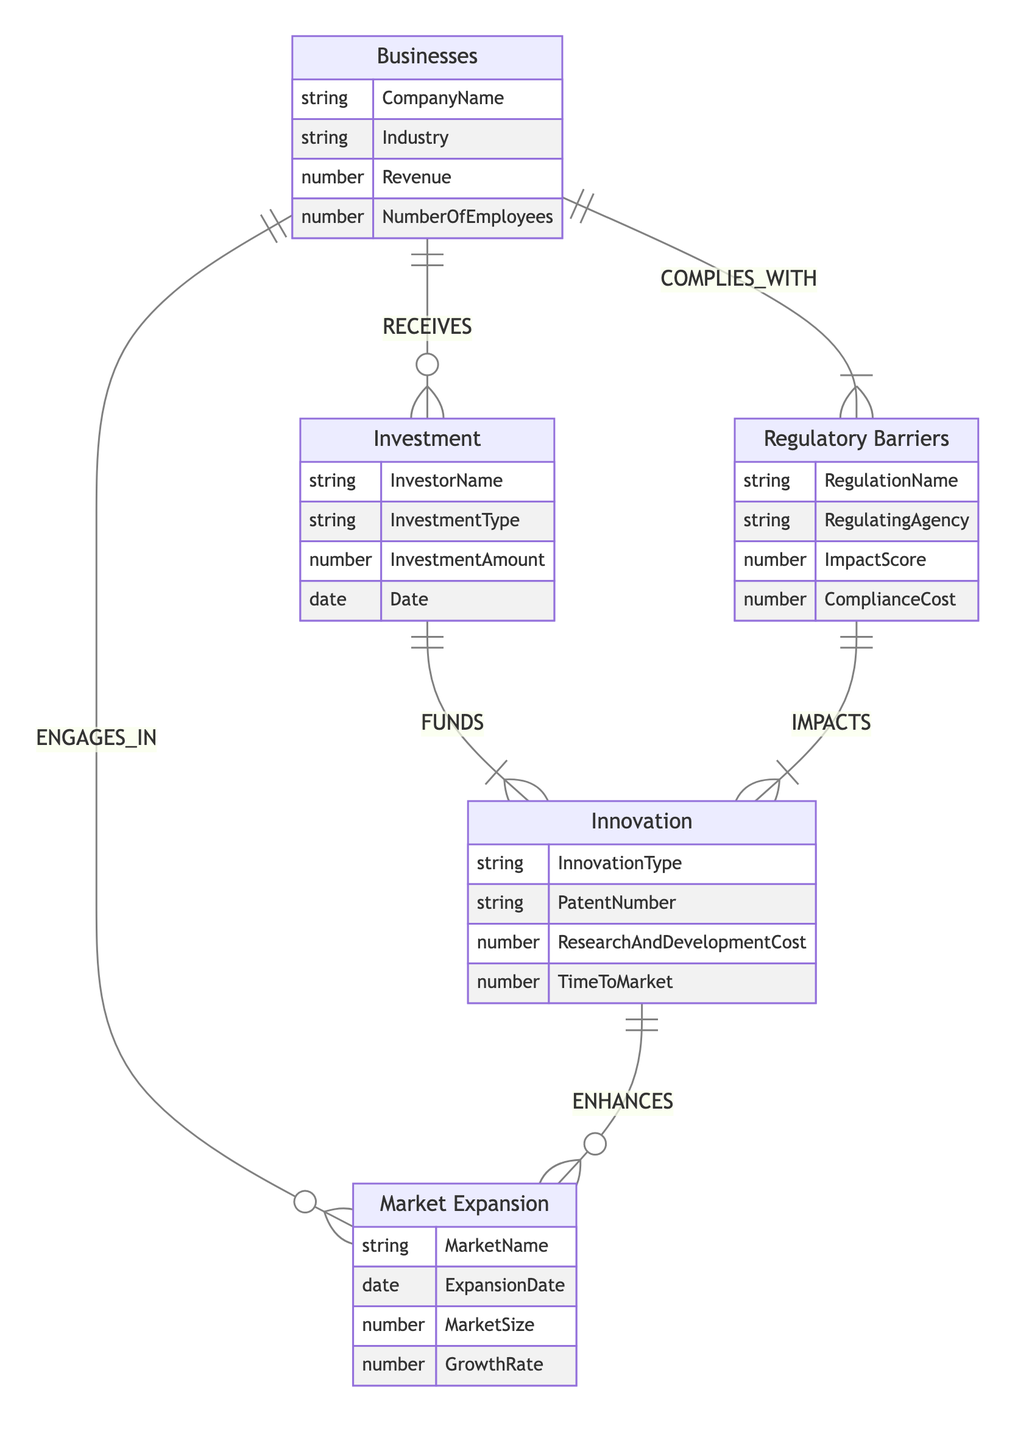What's the relationship type between Businesses and Investment? The diagram indicates that Businesses "RECEIVES" Investment, which means that businesses obtain financial support from investors.
Answer: RECEIVES How many attributes does the Regulatory Barriers entity have? By examining the Regulatory Barriers entity, we can count the attributes listed: RegulationName, RegulatingAgency, ImpactScore, and ComplianceCost. This totals to four attributes.
Answer: 4 What is the relationship type between Regulatory Barriers and Innovation? The diagram specifies that Regulatory Barriers "IMPACTS" Innovation, indicating that regulatory factors influence innovative activities within businesses.
Answer: IMPACTS Which entity engages with Market Expansion? The diagram shows that Businesses "ENGAGES_IN" Market Expansion, meaning that businesses are actively involved in the process of expanding into new markets.
Answer: Businesses What is one attribute of the Innovation entity? The Innovation entity has several attributes including InnovationType, PatentNumber, ResearchAndDevelopmentCost, and TimeToMarket, any of which could be valid answers.
Answer: InnovationType How does Investment affect Innovation? The relationship labeled "FUNDS" indicates that Investment provides financial support for Innovation, highlighting the importance of investments in fostering innovative developments.
Answer: FUNDS What two entities are impacted by Regulatory Barriers? By analyzing the diagram, we see that Regulatory Barriers impact both Innovation and Businesses, showing that regulatory factors can have diverse effects on different entities.
Answer: Innovation, Businesses In what way do Innovations enhance Market Expansion? The diagram describes that Innovation "ENHANCES" Market Expansion, meaning that new innovative developments facilitate or improve the process of entering new markets.
Answer: ENHANCES What is the impact of Compliance Cost regarding Regulatory Barriers? Compliance Cost is an attribute of regulatory barriers, which indicates the financial burden businesses must incur to comply with regulations, affecting economic dynamics.
Answer: ComplianceCost 